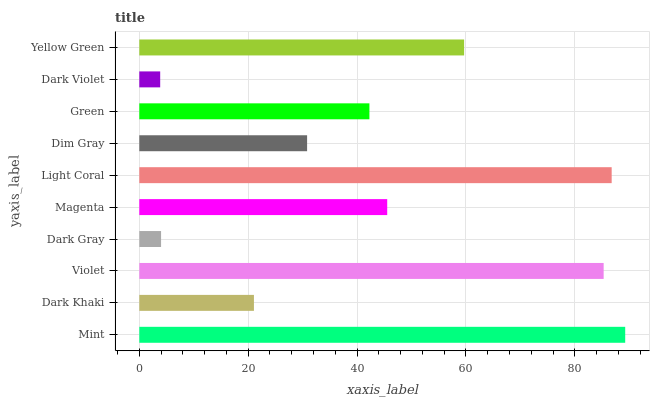Is Dark Violet the minimum?
Answer yes or no. Yes. Is Mint the maximum?
Answer yes or no. Yes. Is Dark Khaki the minimum?
Answer yes or no. No. Is Dark Khaki the maximum?
Answer yes or no. No. Is Mint greater than Dark Khaki?
Answer yes or no. Yes. Is Dark Khaki less than Mint?
Answer yes or no. Yes. Is Dark Khaki greater than Mint?
Answer yes or no. No. Is Mint less than Dark Khaki?
Answer yes or no. No. Is Magenta the high median?
Answer yes or no. Yes. Is Green the low median?
Answer yes or no. Yes. Is Green the high median?
Answer yes or no. No. Is Violet the low median?
Answer yes or no. No. 